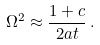Convert formula to latex. <formula><loc_0><loc_0><loc_500><loc_500>\Omega ^ { 2 } \approx \frac { 1 + c } { 2 a t } \, .</formula> 